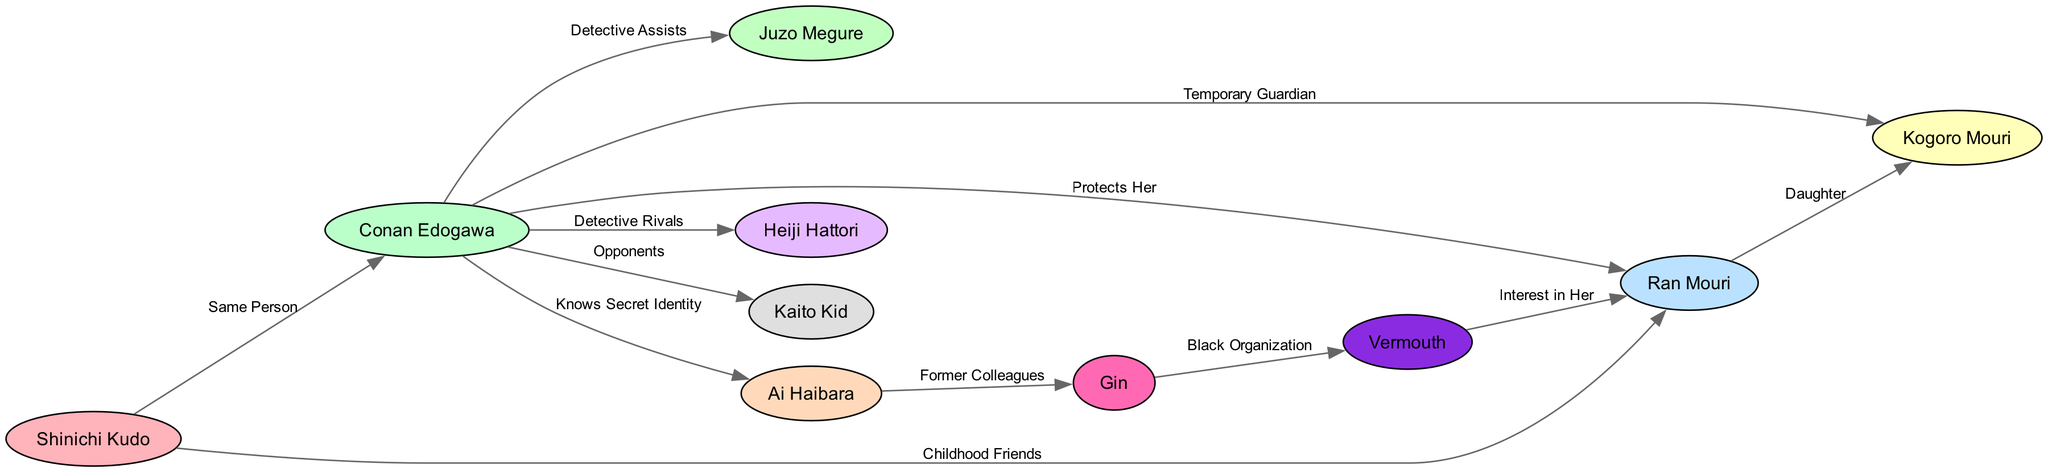What is the label of the edge between Shinichi Kudo and Conan Edogawa? The edge between Shinichi Kudo and Conan Edogawa has the label "Same Person," indicating that both characters are the same individual.
Answer: Same Person How many characters are represented in the diagram? By counting the nodes listed, there are a total of 10 characters depicted in the diagram.
Answer: 10 Who is Ran Mouri's father? The diagram shows an edge from Ran Mouri to Kogoro Mouri labeled "Daughter," which implies that Kogoro Mouri is her father.
Answer: Kogoro Mouri What is the relationship between Conan Edogawa and Ai Haibara? The diagram indicates that Conan Edogawa knows Ai Haibara's secret identity, suggesting a close relationship based on mutual trust.
Answer: Knows Secret Identity Which character has an interest in Ran Mouri? According to the diagram, there is an edge from Vermouth to Ran Mouri labeled "Interest in Her," which shows that Vermouth is interested in Ran.
Answer: Vermouth How many edges connect to Conan Edogawa? There are several edges connecting to Conan Edogawa: to Ran Mouri, Kogoro Mouri, Ai Haibara, Heiji Hattori, Kaito Kid, and Juzo Megure. Upon counting, there are 6 edges.
Answer: 6 What type of relationship do Conan Edogawa and Heiji Hattori share? The edge between Conan Edogawa and Heiji Hattori is labeled "Detective Rivals," categorizing their relationship as competitive.
Answer: Detective Rivals Which character is a former colleague of Ai Haibara? The diagram shows an edge from Ai Haibara to Gin labeled "Former Colleagues," indicating that they used to work together.
Answer: Gin What dynamic exists between Conan Edogawa and Kaito Kid? The diagram suggests that the relationship between Conan Edogawa and Kaito Kid is one of opponents, indicating a conflictual dynamic.
Answer: Opponents Which two characters are associated with the Black Organization? The edge connecting Gin and Vermouth is labeled "Black Organization," thus identifying them as characters linked to this criminal group.
Answer: Gin and Vermouth 